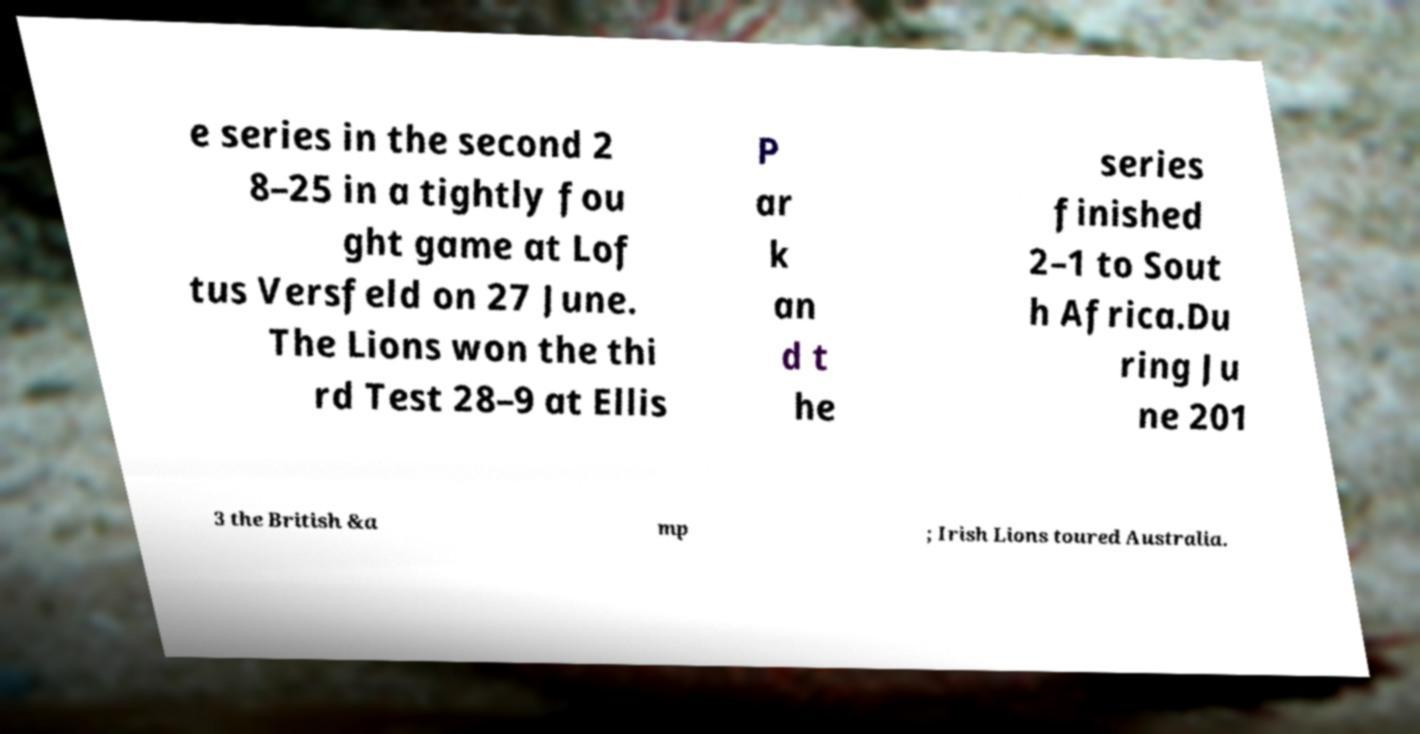Can you read and provide the text displayed in the image?This photo seems to have some interesting text. Can you extract and type it out for me? e series in the second 2 8–25 in a tightly fou ght game at Lof tus Versfeld on 27 June. The Lions won the thi rd Test 28–9 at Ellis P ar k an d t he series finished 2–1 to Sout h Africa.Du ring Ju ne 201 3 the British &a mp ; Irish Lions toured Australia. 